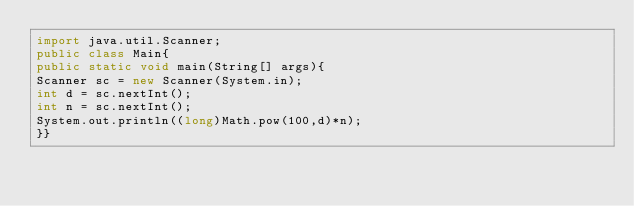<code> <loc_0><loc_0><loc_500><loc_500><_Java_>import java.util.Scanner;
public class Main{
public static void main(String[] args){
Scanner sc = new Scanner(System.in);  
int d = sc.nextInt();
int n = sc.nextInt();
System.out.println((long)Math.pow(100,d)*n);
}}
</code> 